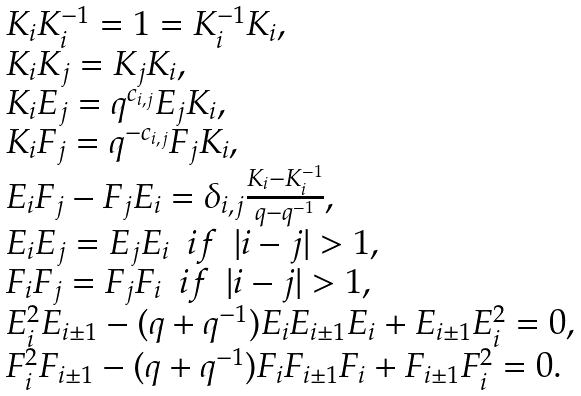Convert formula to latex. <formula><loc_0><loc_0><loc_500><loc_500>\begin{array} { l } K _ { i } K _ { i } ^ { - 1 } = 1 = K _ { i } ^ { - 1 } K _ { i } , \\ K _ { i } K _ { j } = K _ { j } K _ { i } , \\ K _ { i } E _ { j } = q ^ { c _ { i , j } } E _ { j } K _ { i } , \\ K _ { i } F _ { j } = q ^ { - c _ { i , j } } F _ { j } K _ { i } , \\ E _ { i } F _ { j } - F _ { j } E _ { i } = \delta _ { i , j } \frac { K _ { i } - K _ { i } ^ { - 1 } } { q - q ^ { - 1 } } , \\ E _ { i } E _ { j } = E _ { j } E _ { i } \ \ i f \ \ | i - j | > 1 , \\ F _ { i } F _ { j } = F _ { j } F _ { i } \ \ i f \ \ | i - j | > 1 , \\ E _ { i } ^ { 2 } E _ { i \pm 1 } - ( q + q ^ { - 1 } ) E _ { i } E _ { i \pm 1 } E _ { i } + E _ { i \pm 1 } E _ { i } ^ { 2 } = 0 , \\ F _ { i } ^ { 2 } F _ { i \pm 1 } - ( q + q ^ { - 1 } ) F _ { i } F _ { i \pm 1 } F _ { i } + F _ { i \pm 1 } F _ { i } ^ { 2 } = 0 . \end{array}</formula> 